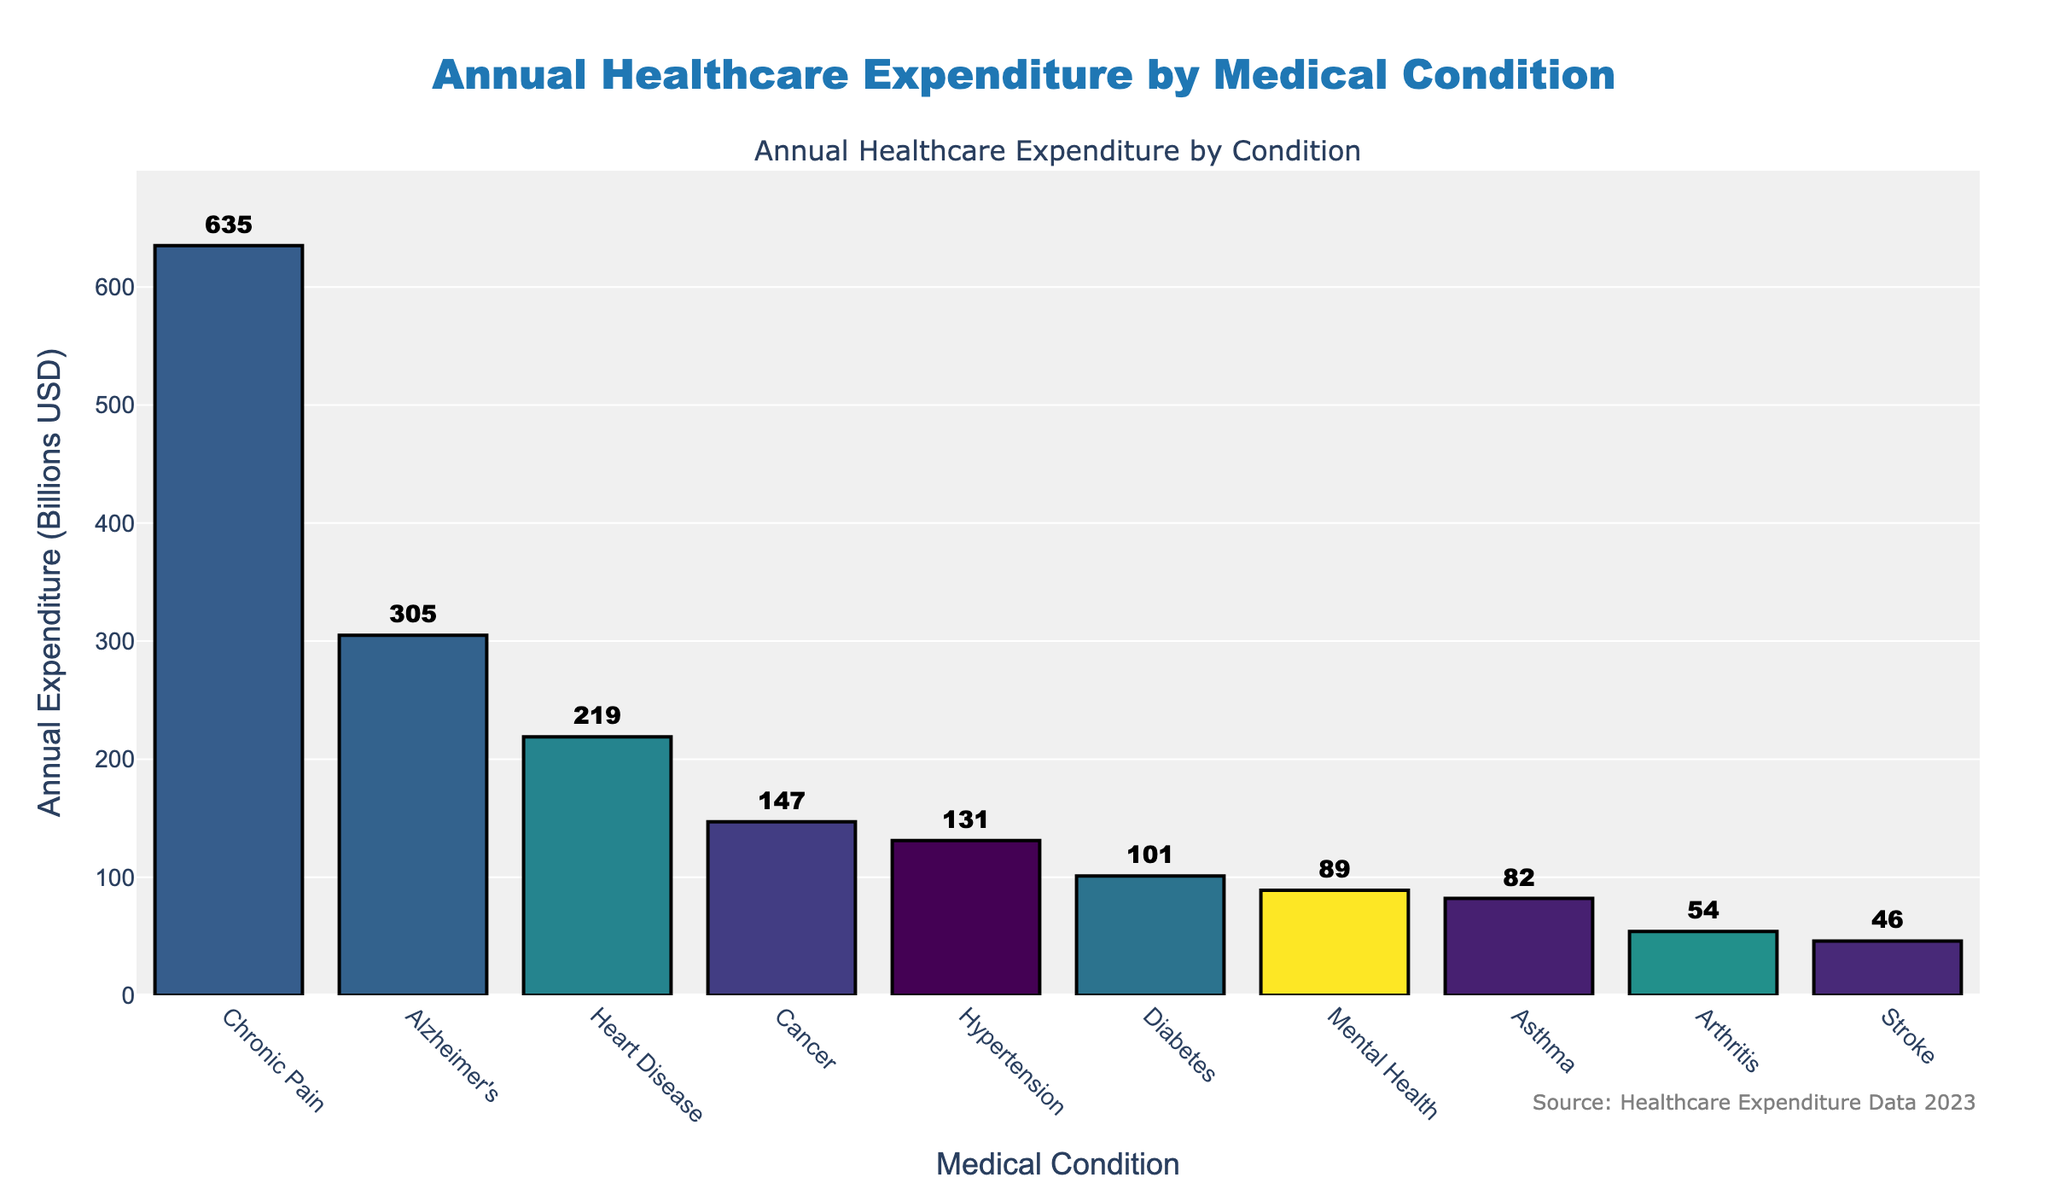What's the total annual expenditure on Heart Disease and Diabetes combined? The expenditure on Heart Disease is $219 billion, and for Diabetes, it's $101 billion. Adding these together: $219B + $101B = $320 billion.
Answer: $320 billion Which condition has the highest annual expenditure? The bar for Chronic Pain is the tallest, indicating it has the highest expenditure at $635 billion.
Answer: Chronic Pain How does the expenditure on Mental Health compare to that on Alzheimer’s? Alzheimer’s has an expenditure of $305 billion, while Mental Health is $89 billion. Since $305 billion is greater than $89 billion, Alzheimer's expenditure is higher than Mental Health’s.
Answer: Alzheimer's expenditure is higher What’s the expenditure difference between the highest and lowest categories? Chronic Pain is the highest at $635 billion, and Stroke is the lowest at $46 billion. The difference is $635B - $46B = $589 billion.
Answer: $589 billion If we rank the conditions from highest to lowest expenditure, where does Cancer place? The conditions ranked from highest to lowest are Chronic Pain, Alzheimer’s, Heart Disease, Hypertension, Diabetes, Cancer, Mental Health, Asthma, Arthritis, and Stroke. Cancer ranks 5th.
Answer: 5th Between which conditions is the expenditure difference exactly $1 billion? The expenditures are: Heart Disease ($219B), Cancer ($147B), Diabetes ($101B), Hypertension ($131B), Asthma ($82B), Arthritis ($54B), Stroke ($46B), and Mental Health ($89B). The difference of $1 billion is between Mental Health ($89B) and Asthma ($82B).
Answer: Mental Health and Asthma What visual elements indicate higher expenditure categories? Taller bars and brighter colors in the plot indicate higher expenditure categories. For example, Chronic Pain has both the tallest bar and one of the brighter colors.
Answer: Taller bars and brighter colors What is the expenditure difference between the categories with the second and third highest expenditures? The second-highest is Alzheimer's at $305 billion, and the third highest is Heart Disease at $219 billion. The difference is $305B - $219B = $86 billion.
Answer: $86 billion What is the average annual expenditure across all conditions? Summing all expenditures gives: 219 + 147 + 89 + 101 + 305 + 54 + 82 + 635 + 131 + 46 = 1809 billion. Dividing by the number of conditions (10), the average is 1809/10 = $180.9 billion.
Answer: $180.9 billion Which condition has an expenditure less than those on Heart Disease but more than on Diabetes? The expenditure for Heart Disease is $219 billion and for Diabetes, it's $101 billion. Cancer, with an expenditure of $147 billion, fits this criterion.
Answer: Cancer 